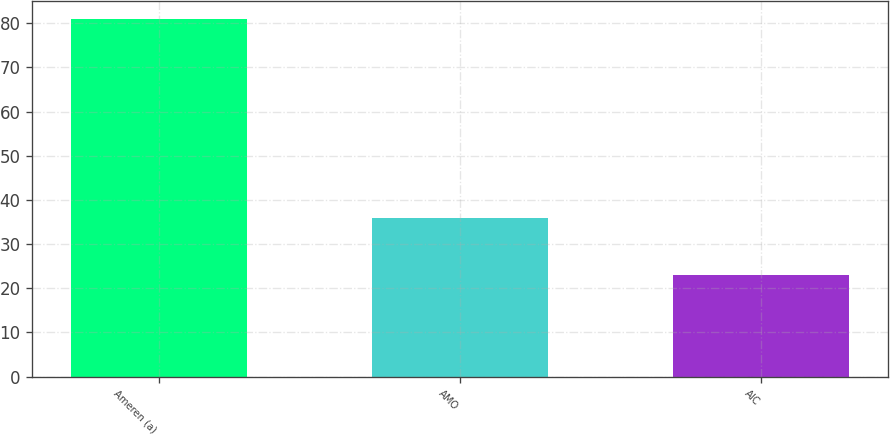<chart> <loc_0><loc_0><loc_500><loc_500><bar_chart><fcel>Ameren (a)<fcel>AMO<fcel>AIC<nl><fcel>81<fcel>36<fcel>23<nl></chart> 